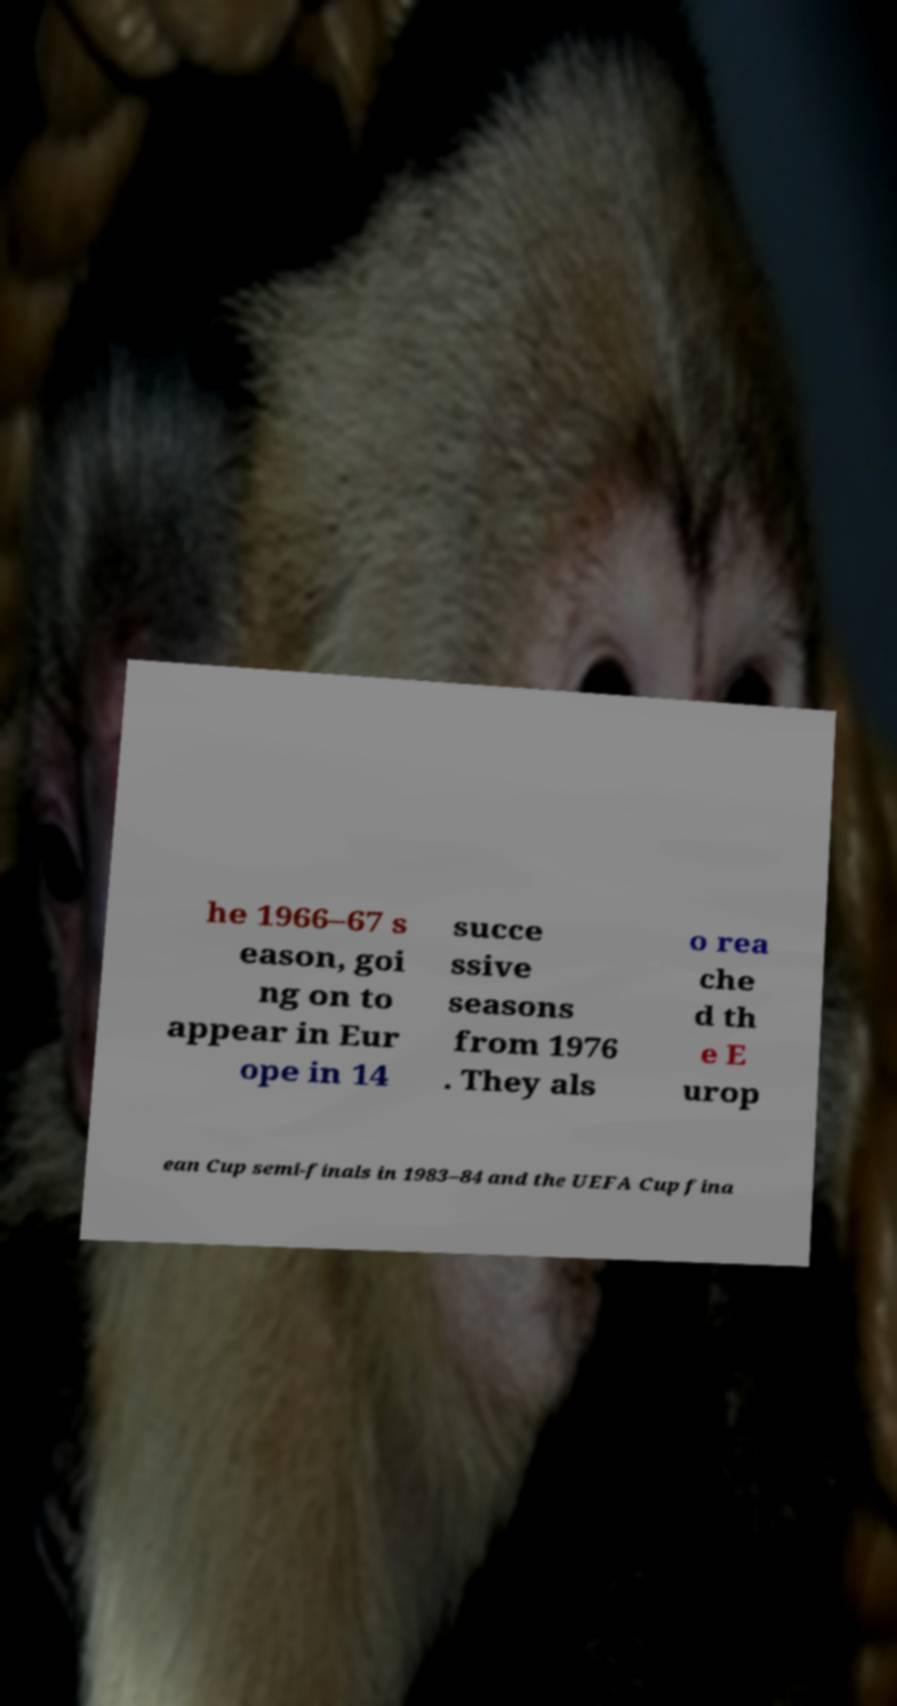What messages or text are displayed in this image? I need them in a readable, typed format. he 1966–67 s eason, goi ng on to appear in Eur ope in 14 succe ssive seasons from 1976 . They als o rea che d th e E urop ean Cup semi-finals in 1983–84 and the UEFA Cup fina 